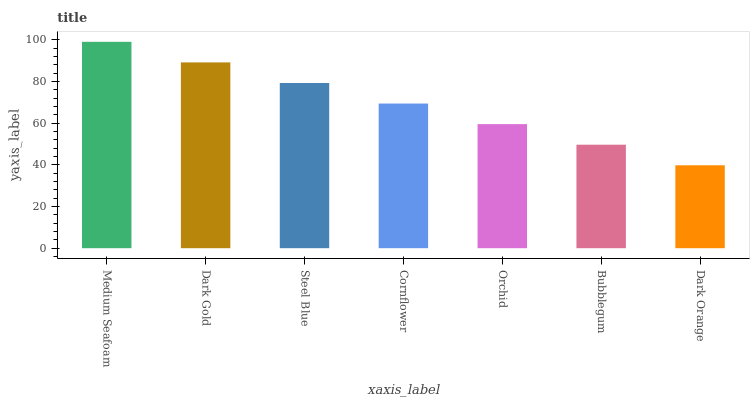Is Dark Gold the minimum?
Answer yes or no. No. Is Dark Gold the maximum?
Answer yes or no. No. Is Medium Seafoam greater than Dark Gold?
Answer yes or no. Yes. Is Dark Gold less than Medium Seafoam?
Answer yes or no. Yes. Is Dark Gold greater than Medium Seafoam?
Answer yes or no. No. Is Medium Seafoam less than Dark Gold?
Answer yes or no. No. Is Cornflower the high median?
Answer yes or no. Yes. Is Cornflower the low median?
Answer yes or no. Yes. Is Dark Orange the high median?
Answer yes or no. No. Is Dark Gold the low median?
Answer yes or no. No. 